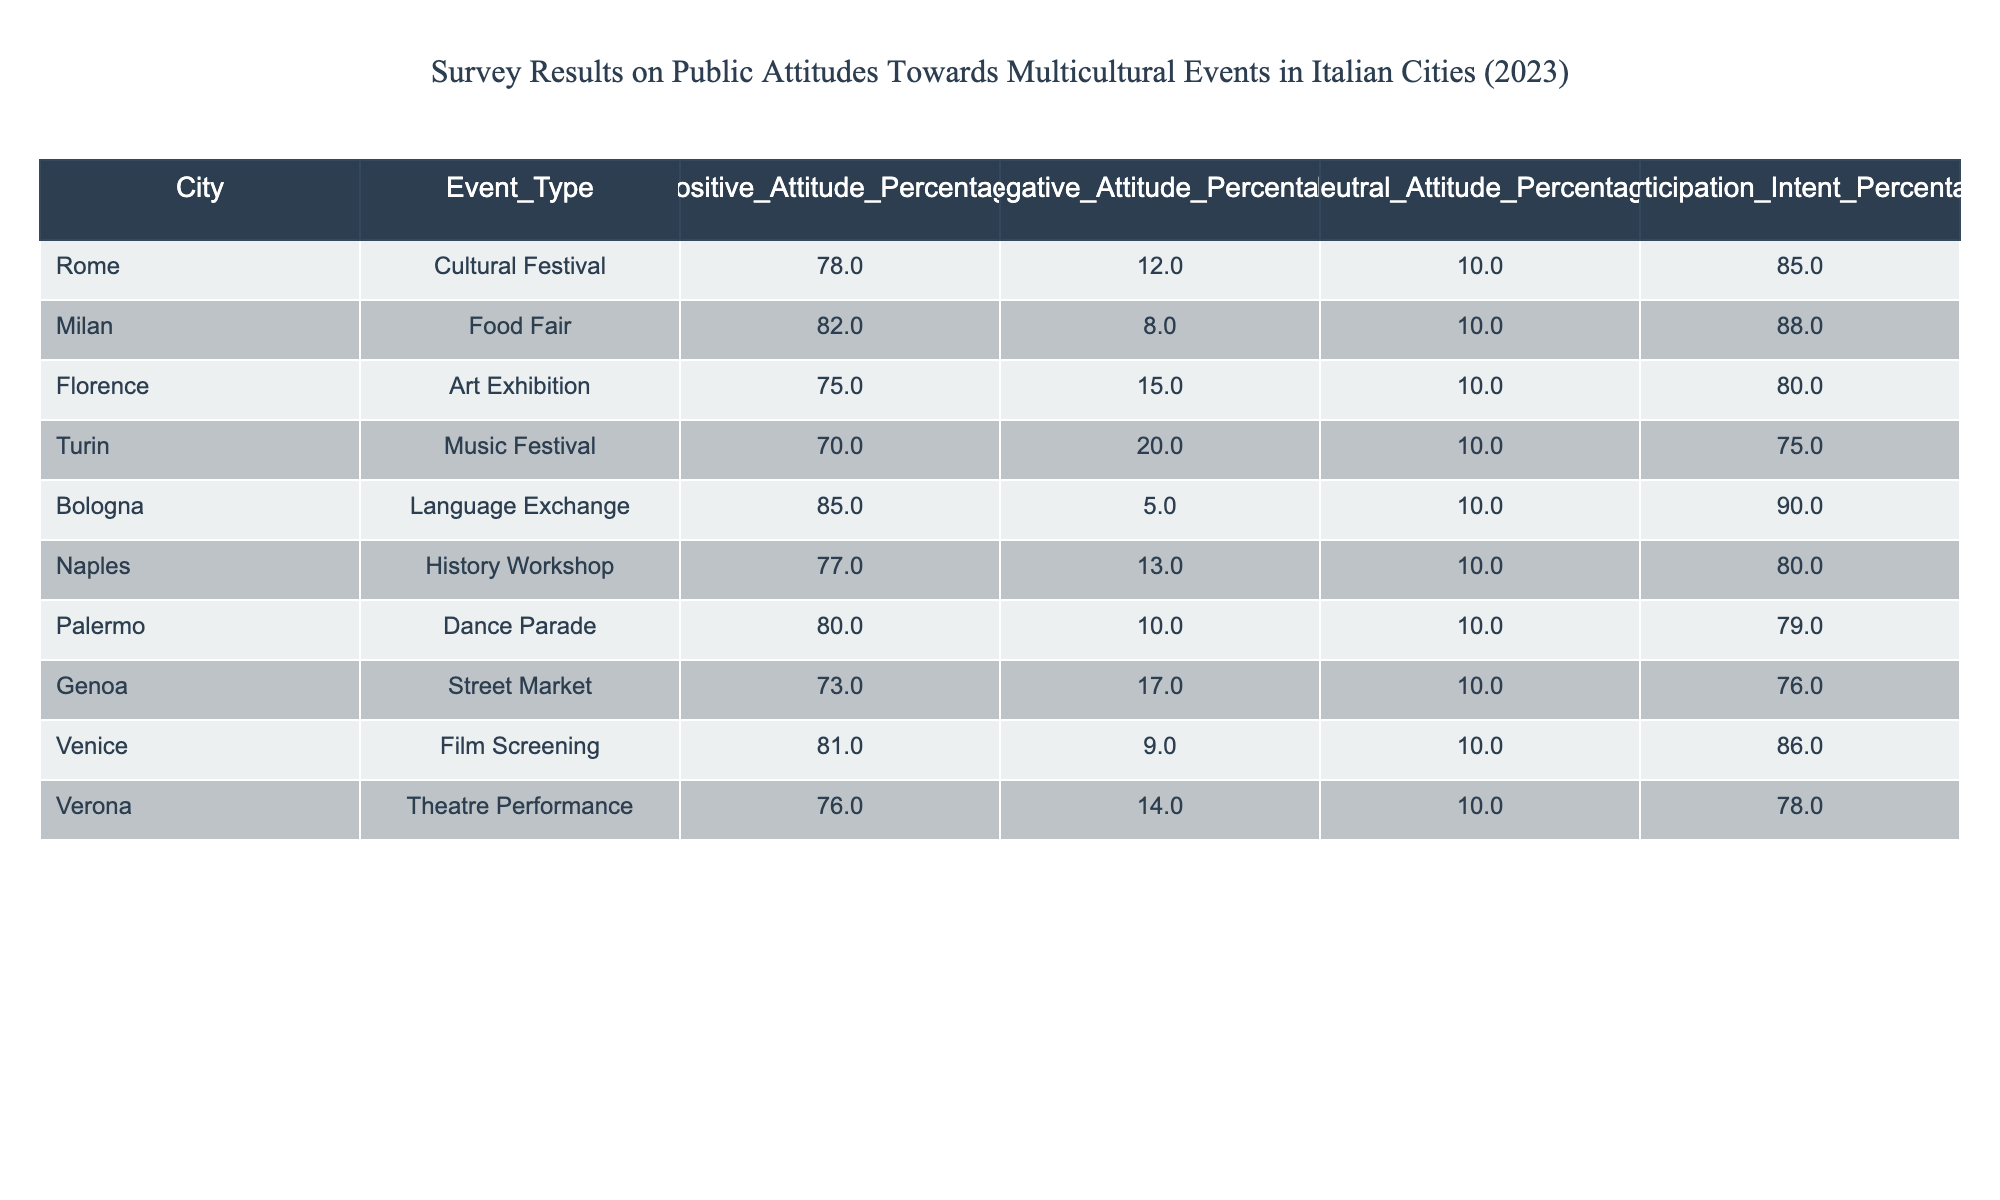What event type had the highest positive attitude percentage? Looking through the table, we can see the positive attitude percentages for each event type across various cities. The "Language Exchange" in Bologna shows the highest positive attitude percentage of 85%.
Answer: Language Exchange Which city's event had the lowest participation intent percentage? The participation intent percentages are listed for each city. Turin's "Music Festival" has the lowest participation intent percentage at 75%.
Answer: Music Festival in Turin What is the average positive attitude percentage across all events? To find the average, we first sum up the positive attitude percentages: (78 + 82 + 75 + 70 + 85 + 77 + 80 + 73 + 81 + 76) = 786. There are 10 events, so the average is 786 / 10 = 78.6%.
Answer: 78.6% Is there any event type with a negative attitude percentage of less than 10%? By reviewing the negative attitude percentages listed for each city, we can see that all percentages are 5% or higher. Therefore, there are no event types with a negative attitude percentage of less than 10%.
Answer: No Which city has a neutral attitude percentage of 10%? The table shows that all cities have a neutral attitude percentage of 10%, as it's consistent across the data.
Answer: All cities 